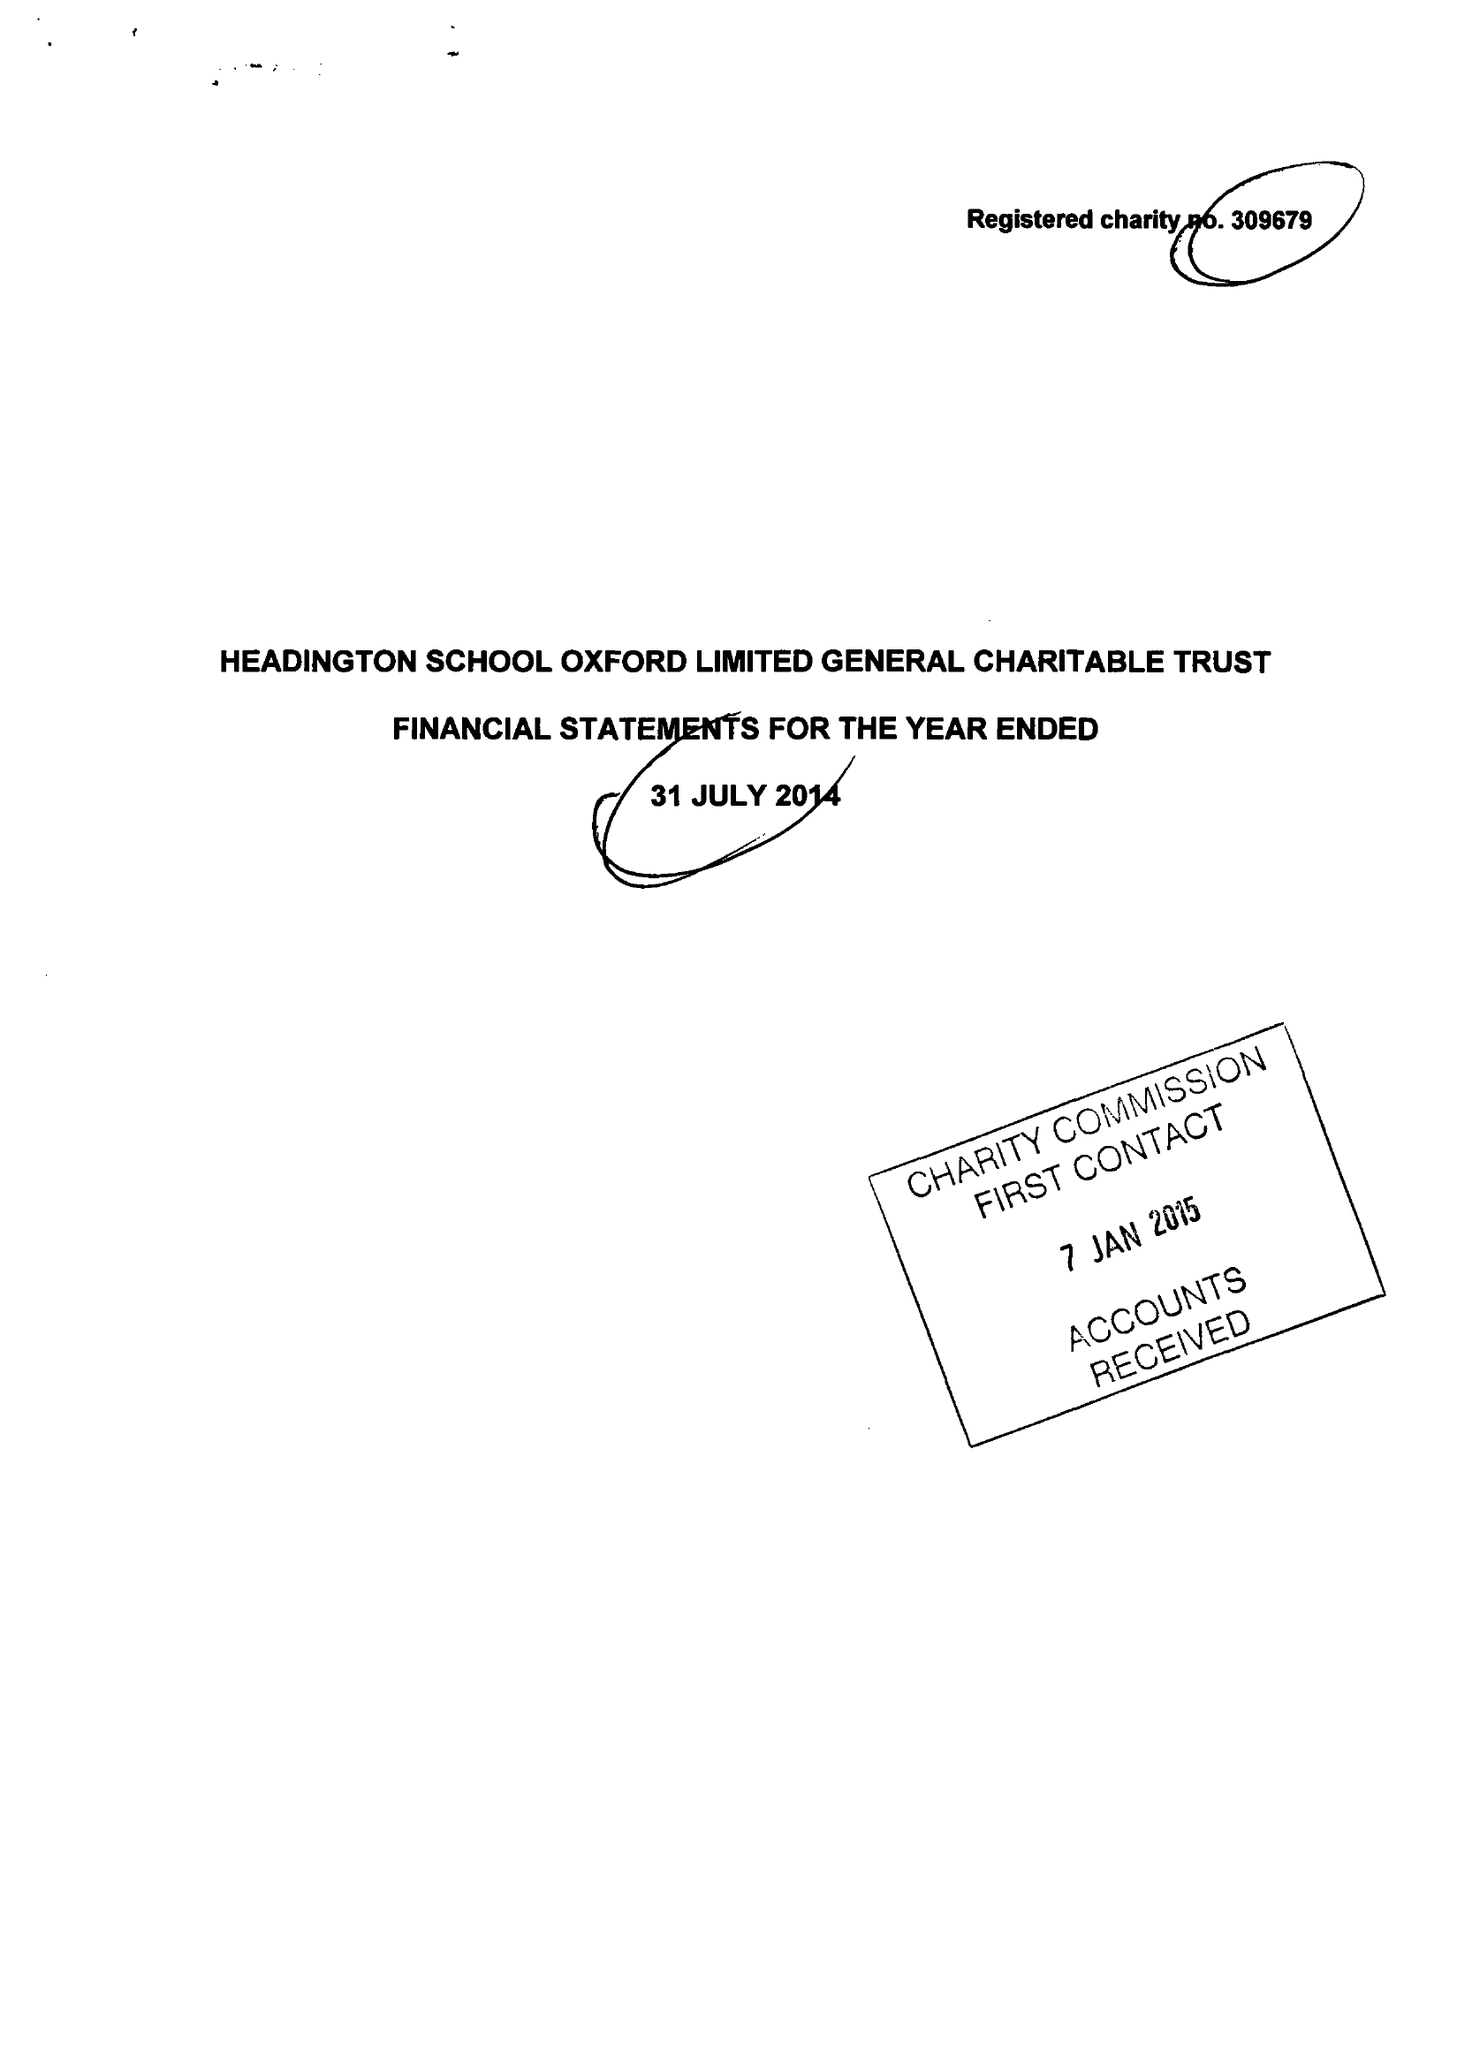What is the value for the address__postcode?
Answer the question using a single word or phrase. OX3 0BL 